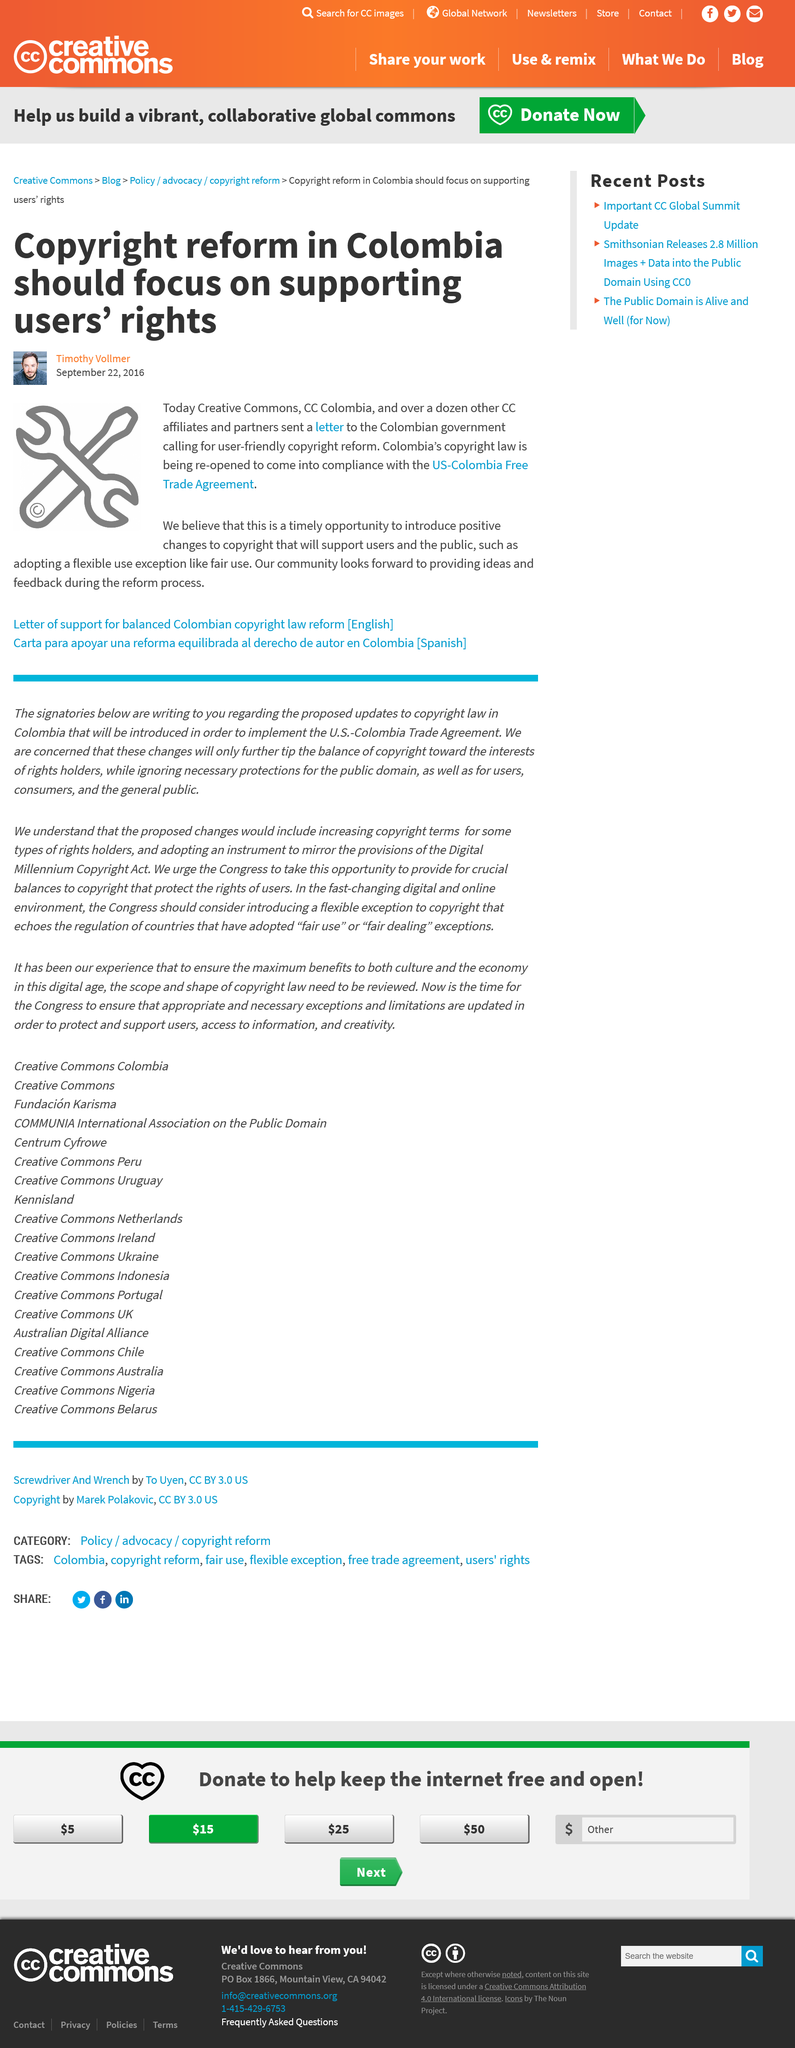Give some essential details in this illustration. CC Colombia aims to introduce positive changes to copyright laws by adopting a flexible use exception, such as fair use, that allows for the use of copyrighted material for purposes such as criticism, commentary, news reporting, teaching, scholarship, or research without obtaining permission from the copyright holder. CC Colombia and its affiliates and partners used a letter as the method of communication to contact the Colombian government. The United States-Colombia Free Trade Agreement will serve as the model for Colombia's compliance with its copyright law. 